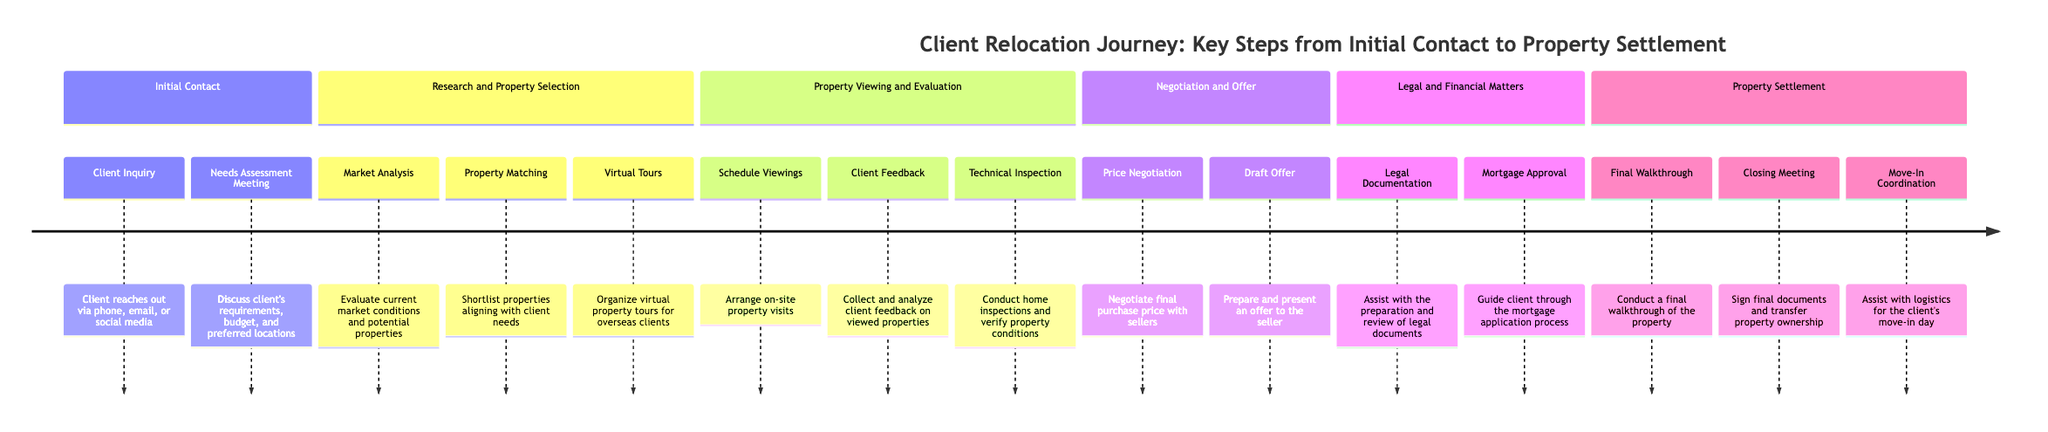What is the first step in the Initial Contact phase? The first step listed under the Initial Contact phase is "Client Inquiry". This is the first mentioned action that starts the relocation journey.
Answer: Client Inquiry How many steps are in the Research and Property Selection phase? The Research and Property Selection phase includes three distinct steps: Market Analysis, Property Matching, and Virtual Tours. Counting these steps gives a total of three.
Answer: 3 What follows the Technical Inspection in the Property Viewing and Evaluation phase? After the Technical Inspection, the next step in the Property Viewing and Evaluation phase is the Negotiation and Offer phase, which begins with Price Negotiation.
Answer: Negotiation and Offer Which phase includes mortgage approval? The phase that includes the Mortgage Approval step is the Legal and Financial Matters phase. This is directly indicated in the diagram as part of the legal and financial process.
Answer: Legal and Financial Matters How many phases are there in total? The timeline consists of five distinct phases: Initial Contact, Research and Property Selection, Property Viewing and Evaluation, Negotiation and Offer, and Legal and Financial Matters, and finally Property Settlement, totaling six phases.
Answer: 6 What is the last step in the Property Settlement phase? The last step of the Property Settlement phase is "Move-In Coordination". This marks the concluding action in the client's relocation process.
Answer: Move-In Coordination What details are discussed during the Needs Assessment Meeting? During the Needs Assessment Meeting, the client's requirements, budget, and preferred locations are discussed, as mentioned in the details for this step.
Answer: Requirements, budget, preferred locations Which step involves final document signing? The step that involves the signing of final documents is "Closing Meeting", as indicated in the Property Settlement phase.
Answer: Closing Meeting How many steps are there before the Property Settlement phase begins? To find how many steps occur before the Property Settlement phase, we count all the steps from the previous phases: 2 (Initial Contact) + 3 (Research and Property Selection) + 3 (Property Viewing and Evaluation) + 2 (Negotiation and Offer) + 2 (Legal and Financial Matters) = 12 steps.
Answer: 12 